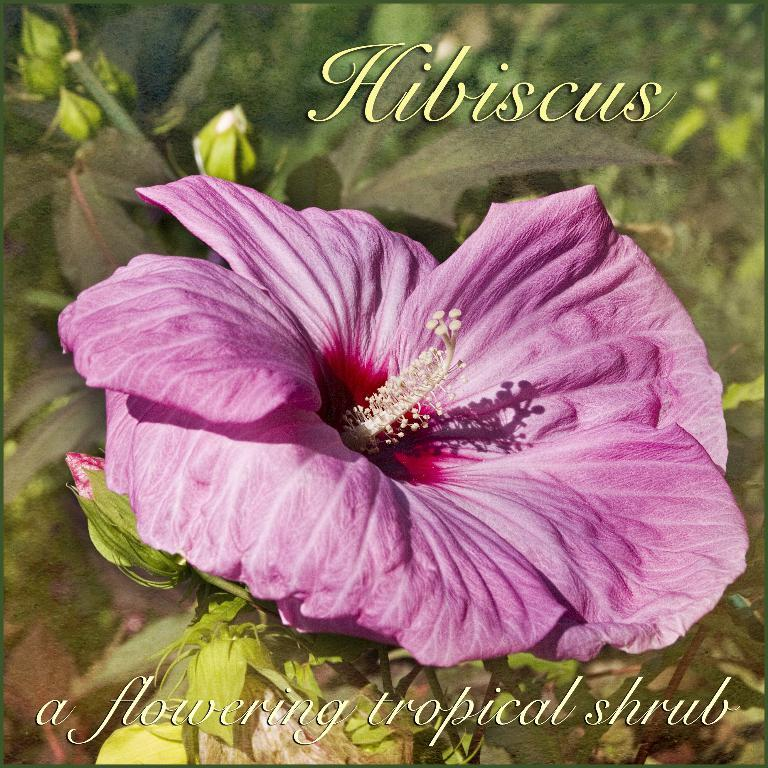What type of image is depicted in the poster? The image is a poster. What is the main subject of the poster? There is a plant with hibiscus flowers on the poster. Are there any additional features on the poster? Yes, there are watermarks on the poster. How many apples are hanging from the branches of the plant on the poster? There are no apples present on the plant in the poster; it has hibiscus flowers. What type of ship can be seen sailing in the background of the poster? There is no ship visible in the background of the poster; it features a plant with hibiscus flowers and watermarks. 